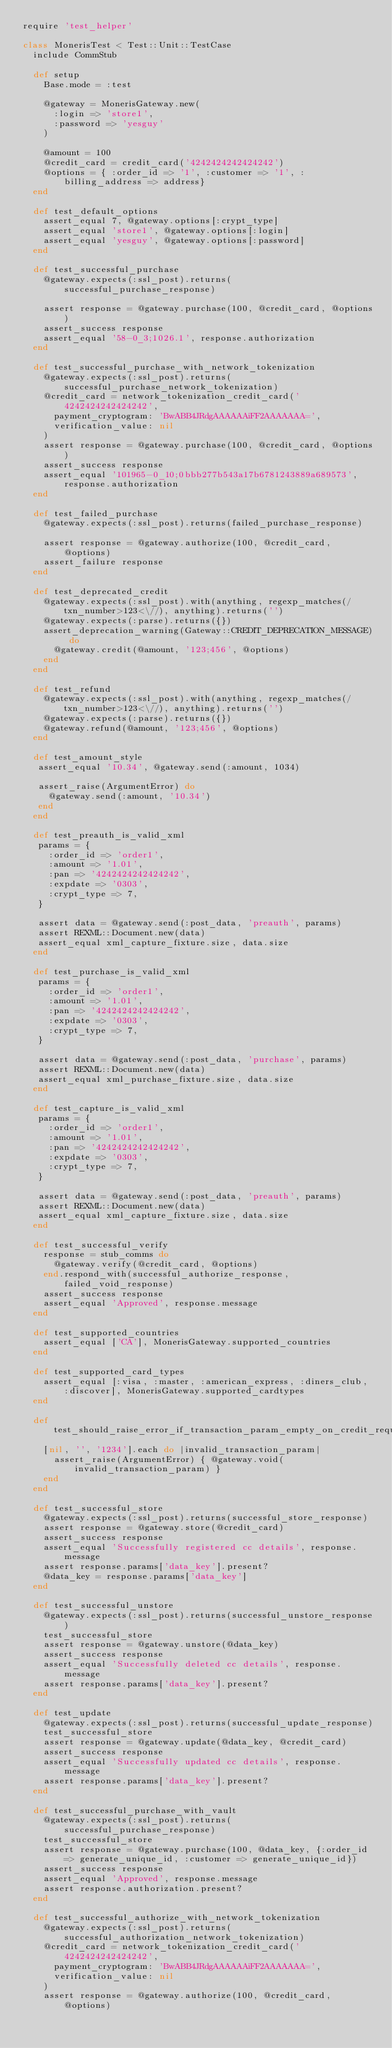Convert code to text. <code><loc_0><loc_0><loc_500><loc_500><_Ruby_>require 'test_helper'

class MonerisTest < Test::Unit::TestCase
  include CommStub

  def setup
    Base.mode = :test

    @gateway = MonerisGateway.new(
      :login => 'store1',
      :password => 'yesguy'
    )

    @amount = 100
    @credit_card = credit_card('4242424242424242')
    @options = { :order_id => '1', :customer => '1', :billing_address => address}
  end

  def test_default_options
    assert_equal 7, @gateway.options[:crypt_type]
    assert_equal 'store1', @gateway.options[:login]
    assert_equal 'yesguy', @gateway.options[:password]
  end

  def test_successful_purchase
    @gateway.expects(:ssl_post).returns(successful_purchase_response)

    assert response = @gateway.purchase(100, @credit_card, @options)
    assert_success response
    assert_equal '58-0_3;1026.1', response.authorization
  end

  def test_successful_purchase_with_network_tokenization
    @gateway.expects(:ssl_post).returns(successful_purchase_network_tokenization)
    @credit_card = network_tokenization_credit_card('4242424242424242',
      payment_cryptogram: 'BwABB4JRdgAAAAAAiFF2AAAAAAA=',
      verification_value: nil
    )
    assert response = @gateway.purchase(100, @credit_card, @options)
    assert_success response
    assert_equal '101965-0_10;0bbb277b543a17b6781243889a689573', response.authorization
  end

  def test_failed_purchase
    @gateway.expects(:ssl_post).returns(failed_purchase_response)

    assert response = @gateway.authorize(100, @credit_card, @options)
    assert_failure response
  end

  def test_deprecated_credit
    @gateway.expects(:ssl_post).with(anything, regexp_matches(/txn_number>123<\//), anything).returns('')
    @gateway.expects(:parse).returns({})
    assert_deprecation_warning(Gateway::CREDIT_DEPRECATION_MESSAGE) do
      @gateway.credit(@amount, '123;456', @options)
    end
  end

  def test_refund
    @gateway.expects(:ssl_post).with(anything, regexp_matches(/txn_number>123<\//), anything).returns('')
    @gateway.expects(:parse).returns({})
    @gateway.refund(@amount, '123;456', @options)
  end

  def test_amount_style
   assert_equal '10.34', @gateway.send(:amount, 1034)

   assert_raise(ArgumentError) do
     @gateway.send(:amount, '10.34')
   end
  end

  def test_preauth_is_valid_xml
   params = {
     :order_id => 'order1',
     :amount => '1.01',
     :pan => '4242424242424242',
     :expdate => '0303',
     :crypt_type => 7,
   }

   assert data = @gateway.send(:post_data, 'preauth', params)
   assert REXML::Document.new(data)
   assert_equal xml_capture_fixture.size, data.size
  end

  def test_purchase_is_valid_xml
   params = {
     :order_id => 'order1',
     :amount => '1.01',
     :pan => '4242424242424242',
     :expdate => '0303',
     :crypt_type => 7,
   }

   assert data = @gateway.send(:post_data, 'purchase', params)
   assert REXML::Document.new(data)
   assert_equal xml_purchase_fixture.size, data.size
  end

  def test_capture_is_valid_xml
   params = {
     :order_id => 'order1',
     :amount => '1.01',
     :pan => '4242424242424242',
     :expdate => '0303',
     :crypt_type => 7,
   }

   assert data = @gateway.send(:post_data, 'preauth', params)
   assert REXML::Document.new(data)
   assert_equal xml_capture_fixture.size, data.size
  end

  def test_successful_verify
    response = stub_comms do
      @gateway.verify(@credit_card, @options)
    end.respond_with(successful_authorize_response, failed_void_response)
    assert_success response
    assert_equal 'Approved', response.message
  end

  def test_supported_countries
    assert_equal ['CA'], MonerisGateway.supported_countries
  end

  def test_supported_card_types
    assert_equal [:visa, :master, :american_express, :diners_club, :discover], MonerisGateway.supported_cardtypes
  end

  def test_should_raise_error_if_transaction_param_empty_on_credit_request
    [nil, '', '1234'].each do |invalid_transaction_param|
      assert_raise(ArgumentError) { @gateway.void(invalid_transaction_param) }
    end
  end

  def test_successful_store
    @gateway.expects(:ssl_post).returns(successful_store_response)
    assert response = @gateway.store(@credit_card)
    assert_success response
    assert_equal 'Successfully registered cc details', response.message
    assert response.params['data_key'].present?
    @data_key = response.params['data_key']
  end

  def test_successful_unstore
    @gateway.expects(:ssl_post).returns(successful_unstore_response)
    test_successful_store
    assert response = @gateway.unstore(@data_key)
    assert_success response
    assert_equal 'Successfully deleted cc details', response.message
    assert response.params['data_key'].present?
  end

  def test_update
    @gateway.expects(:ssl_post).returns(successful_update_response)
    test_successful_store
    assert response = @gateway.update(@data_key, @credit_card)
    assert_success response
    assert_equal 'Successfully updated cc details', response.message
    assert response.params['data_key'].present?
  end

  def test_successful_purchase_with_vault
    @gateway.expects(:ssl_post).returns(successful_purchase_response)
    test_successful_store
    assert response = @gateway.purchase(100, @data_key, {:order_id => generate_unique_id, :customer => generate_unique_id})
    assert_success response
    assert_equal 'Approved', response.message
    assert response.authorization.present?
  end

  def test_successful_authorize_with_network_tokenization
    @gateway.expects(:ssl_post).returns(successful_authorization_network_tokenization)
    @credit_card = network_tokenization_credit_card('4242424242424242',
      payment_cryptogram: 'BwABB4JRdgAAAAAAiFF2AAAAAAA=',
      verification_value: nil
    )
    assert response = @gateway.authorize(100, @credit_card, @options)</code> 